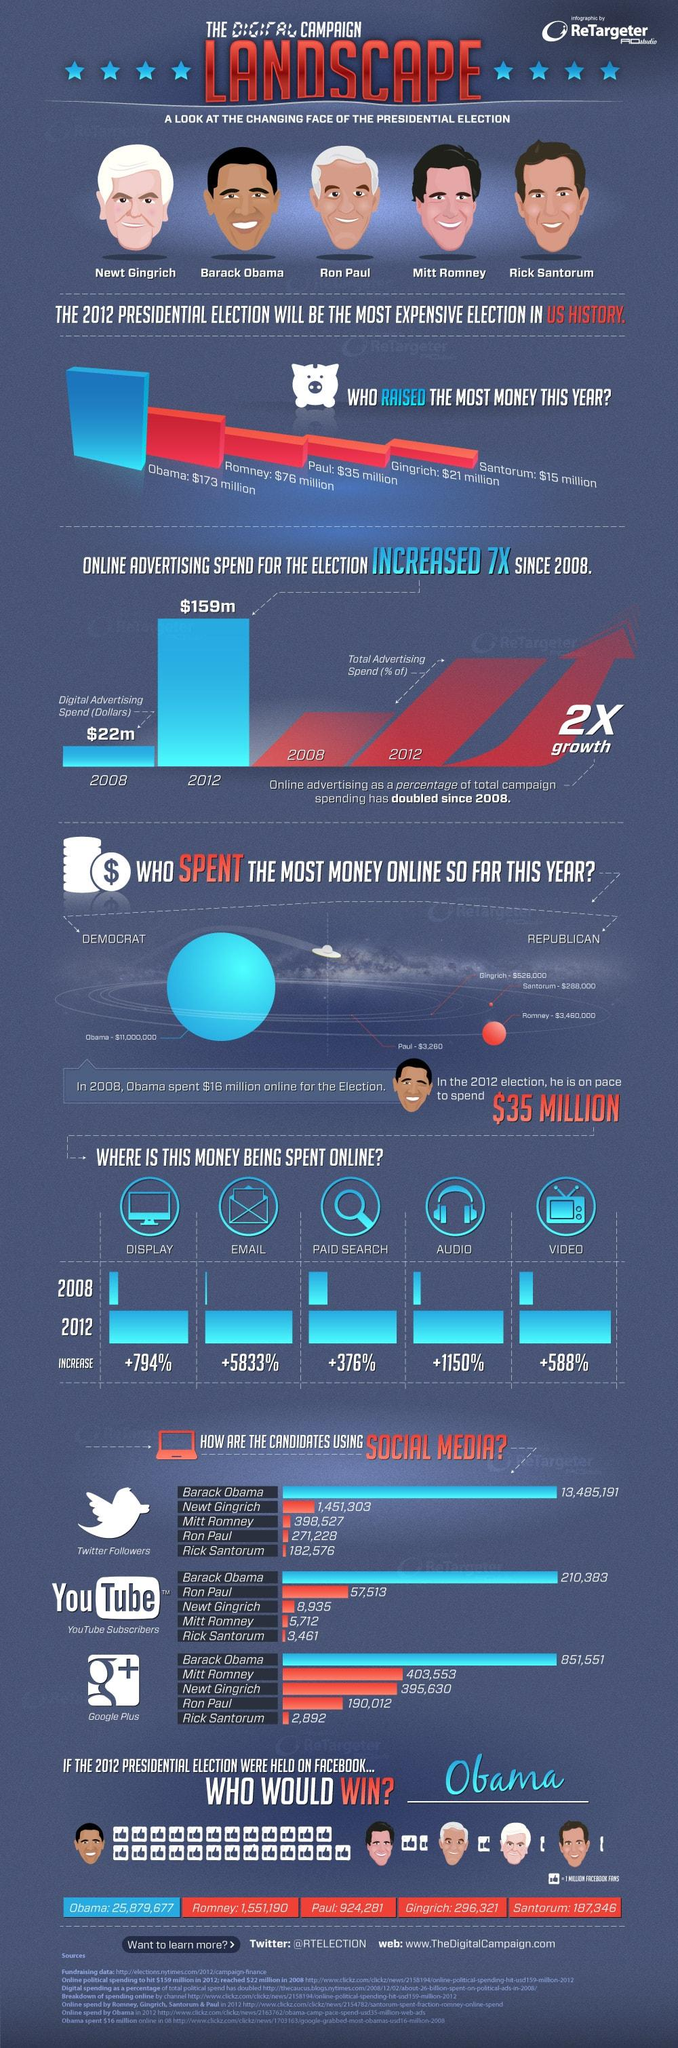Give some essential details in this illustration. Between 2008 and 2012, the amount of money spent on digital advertising increased by $137 million. If the election for Mitt Romney were held on Facebook, he would have received approximately 1,551,190 likes. It is stated that 7 sources are listed at the bottom. According to the information provided, Barack Obama has the most number of followers in all three platforms: Twitter, YouTube, and Google Plus. In 2012, Barack Obama raised the most money among all candidates in the election. 